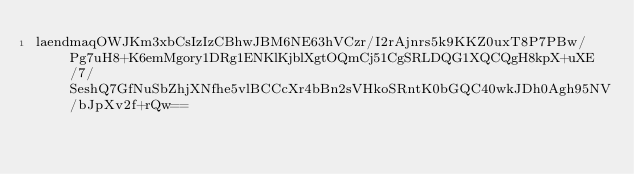<code> <loc_0><loc_0><loc_500><loc_500><_SML_>laendmaqOWJKm3xbCsIzIzCBhwJBM6NE63hVCzr/I2rAjnrs5k9KKZ0uxT8P7PBw/Pg7uH8+K6emMgory1DRg1ENKlKjblXgtOQmCj51CgSRLDQG1XQCQgH8kpX+uXE/7/SeshQ7GfNuSbZhjXNfhe5vlBCCcXr4bBn2sVHkoSRntK0bGQC40wkJDh0Agh95NV/bJpXv2f+rQw==</code> 